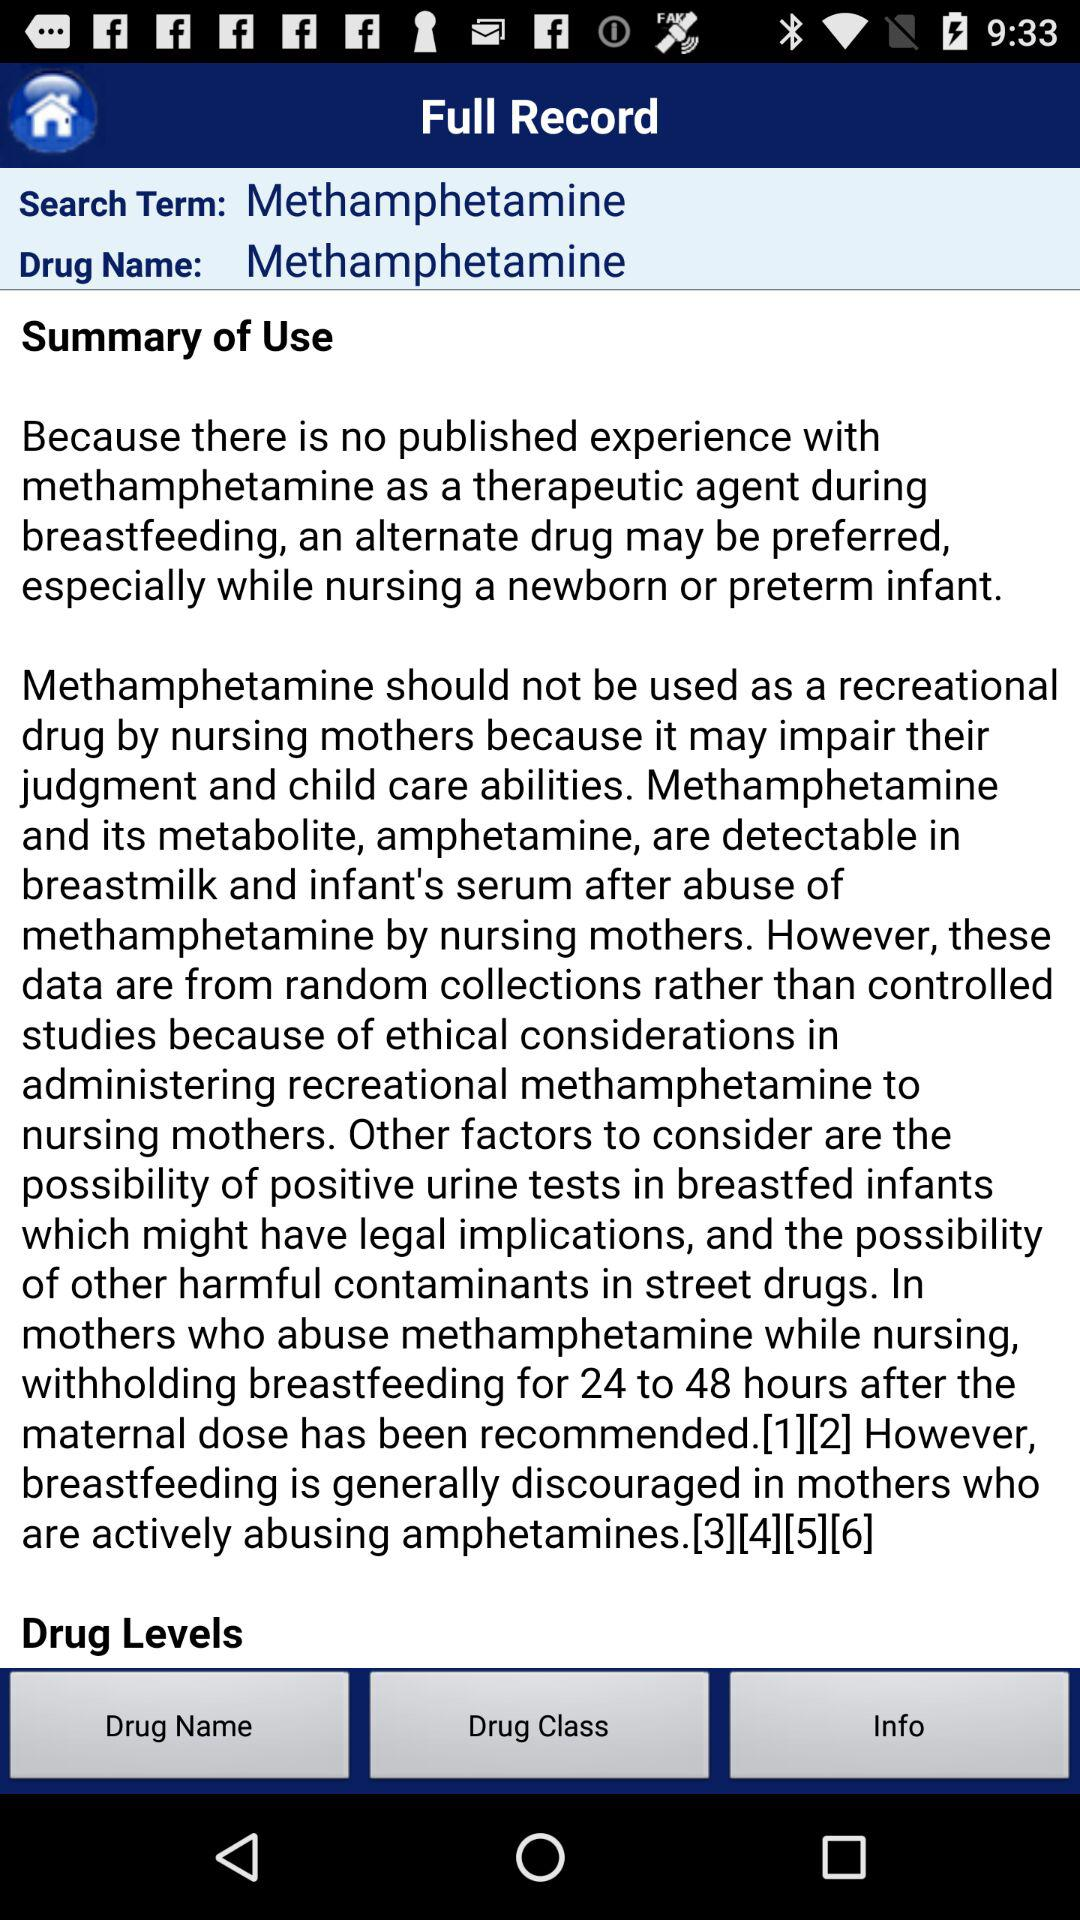What is the drug's name? The drug's name is methamphetamine. 